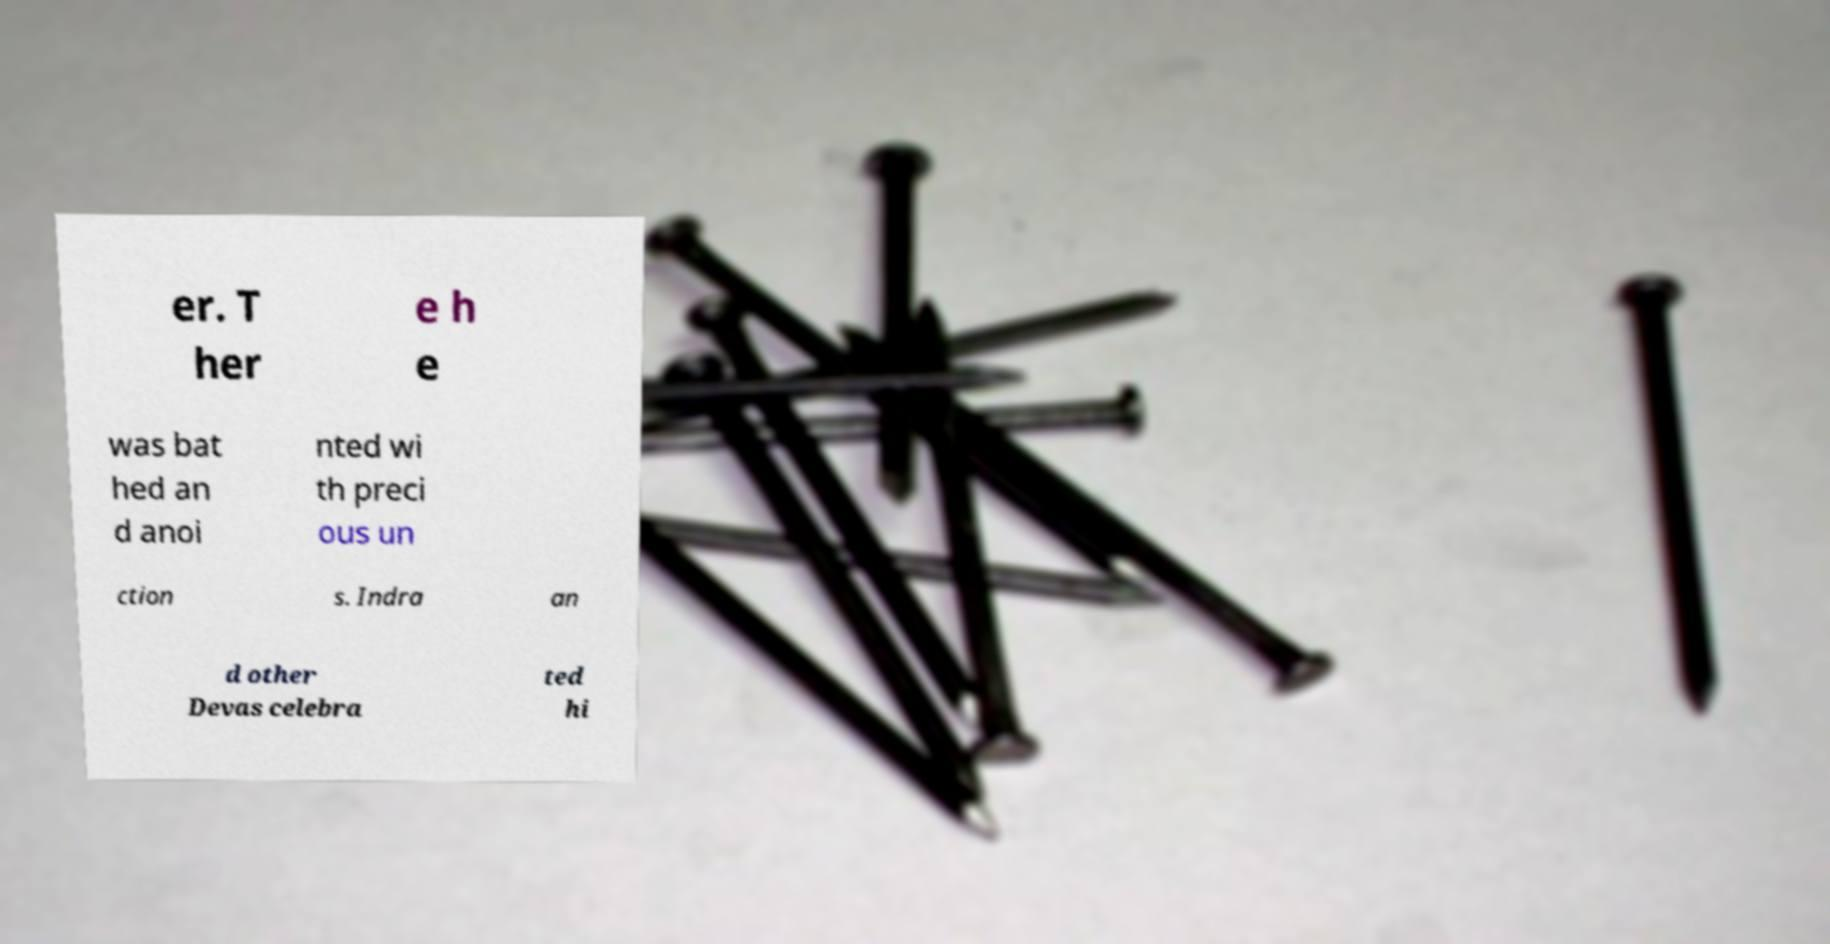Can you read and provide the text displayed in the image?This photo seems to have some interesting text. Can you extract and type it out for me? er. T her e h e was bat hed an d anoi nted wi th preci ous un ction s. Indra an d other Devas celebra ted hi 